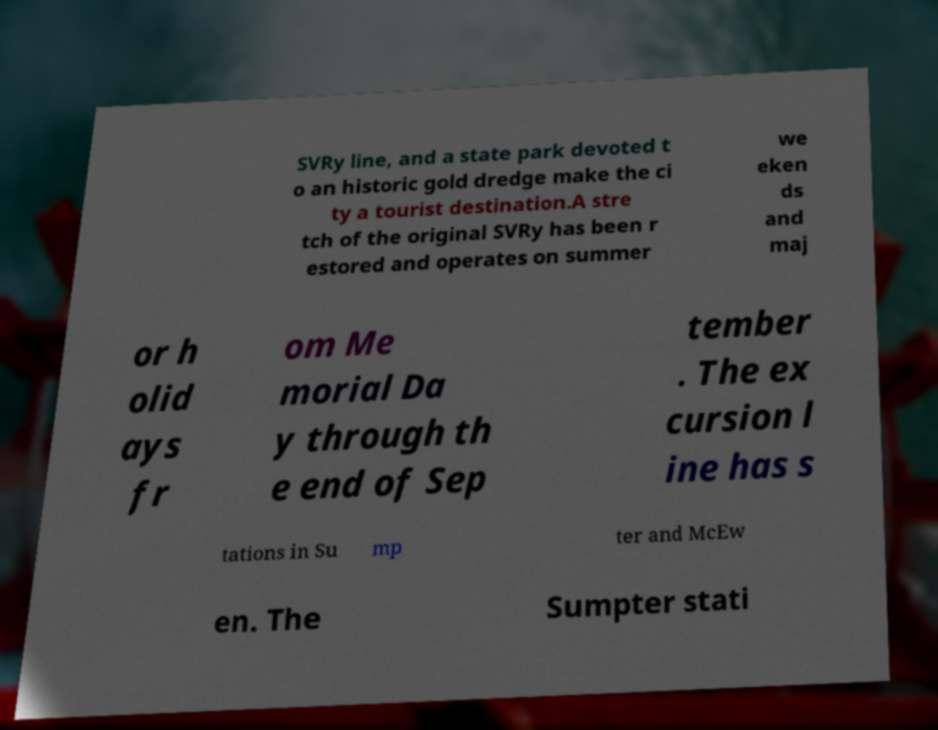I need the written content from this picture converted into text. Can you do that? SVRy line, and a state park devoted t o an historic gold dredge make the ci ty a tourist destination.A stre tch of the original SVRy has been r estored and operates on summer we eken ds and maj or h olid ays fr om Me morial Da y through th e end of Sep tember . The ex cursion l ine has s tations in Su mp ter and McEw en. The Sumpter stati 